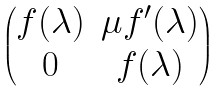Convert formula to latex. <formula><loc_0><loc_0><loc_500><loc_500>\begin{pmatrix} f ( \lambda ) & \mu f ^ { \prime } ( \lambda ) \\ 0 & f ( \lambda ) \end{pmatrix}</formula> 